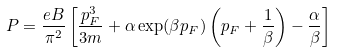<formula> <loc_0><loc_0><loc_500><loc_500>P = \frac { e B } { \pi ^ { 2 } } \left [ \frac { p _ { F } ^ { 3 } } { 3 m } + \alpha \exp ( \beta p _ { F } ) \left ( p _ { F } + \frac { 1 } { \beta } \right ) - \frac { \alpha } { \beta } \right ]</formula> 